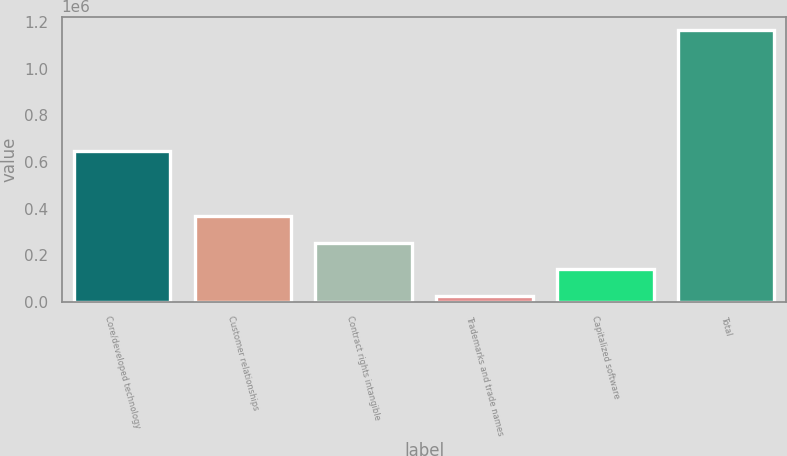Convert chart to OTSL. <chart><loc_0><loc_0><loc_500><loc_500><bar_chart><fcel>Core/developed technology<fcel>Customer relationships<fcel>Contract rights intangible<fcel>Trademarks and trade names<fcel>Capitalized software<fcel>Total<nl><fcel>647975<fcel>367590<fcel>253503<fcel>25329<fcel>139416<fcel>1.1662e+06<nl></chart> 